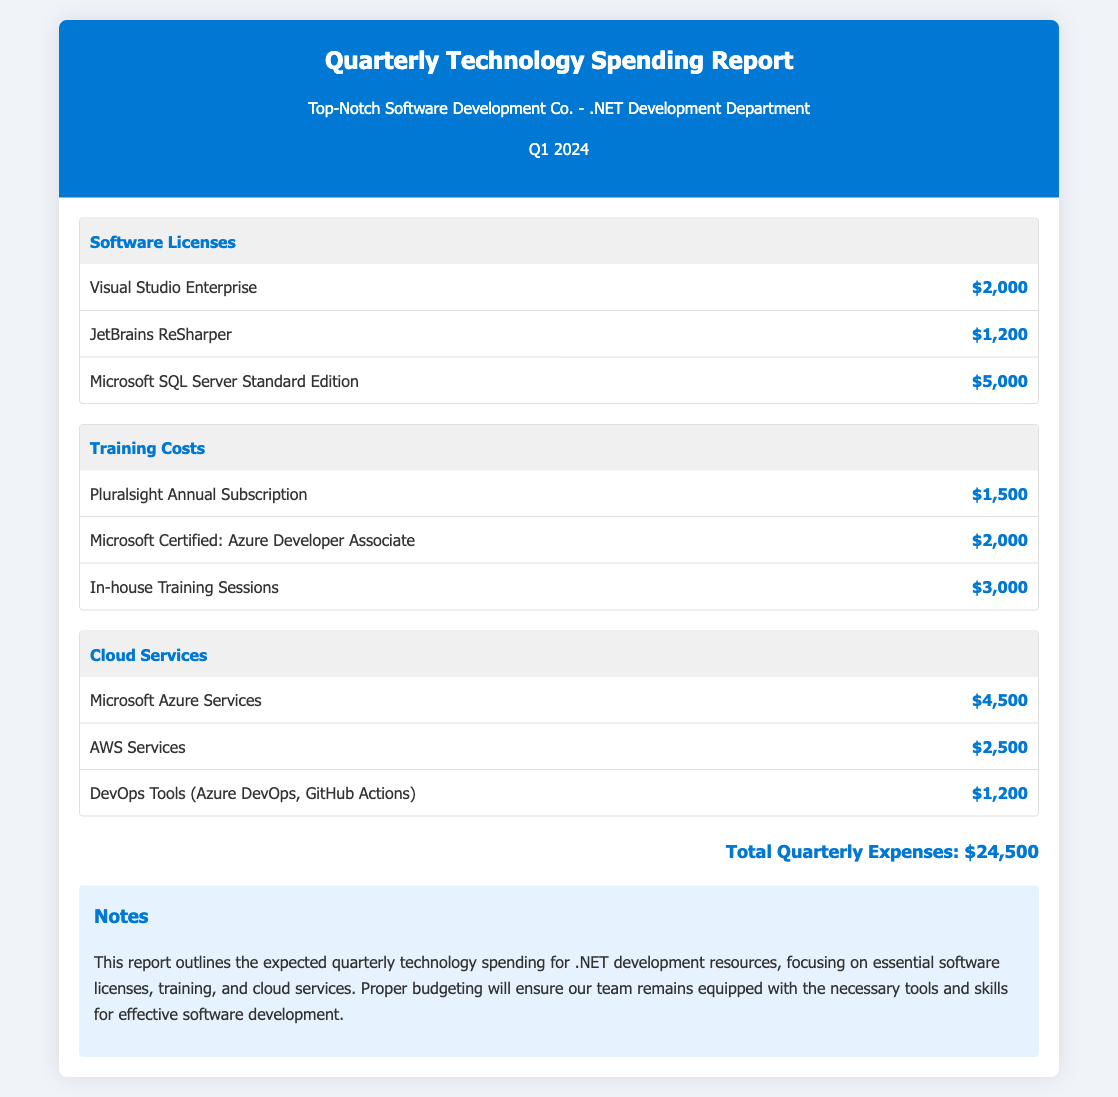What is the total quarterly expenses? The total quarterly expenses is clearly stated at the bottom of the document as $24,500.
Answer: $24,500 How much did the company spend on Visual Studio Enterprise? The cost of Visual Studio Enterprise is listed under Software Licenses as $2,000.
Answer: $2,000 What is the cost of the Microsoft Certified: Azure Developer Associate training? The training cost for Microsoft Certified: Azure Developer Associate is mentioned as $2,000 under Training Costs.
Answer: $2,000 Which cloud service incurred a higher expense, Microsoft Azure Services or AWS Services? By comparing the costs listed in Cloud Services, Microsoft Azure Services costs $4,500 while AWS Services costs $2,500.
Answer: Microsoft Azure Services What is the total spent on Training Costs? The Training Costs are calculated by adding $1,500, $2,000, and $3,000 together, giving a total of $6,500.
Answer: $6,500 How many software licenses are listed in the document? The document lists three software licenses: Visual Studio Enterprise, JetBrains ReSharper, and Microsoft SQL Server Standard Edition.
Answer: Three What is the highest individual expense in the Software Licenses category? The highest individual expense in Software Licenses is Microsoft SQL Server Standard Edition, which costs $5,000.
Answer: $5,000 What is the total cost for the cloud services listed? The total for cloud services is derived from the sum of $4,500, $2,500, and $1,200, leading to $8,200.
Answer: $8,200 How many items are included under Training Costs? The document mentions three items: Pluralsight Annual Subscription, Microsoft Certified: Azure Developer Associate, and In-house Training Sessions.
Answer: Three 